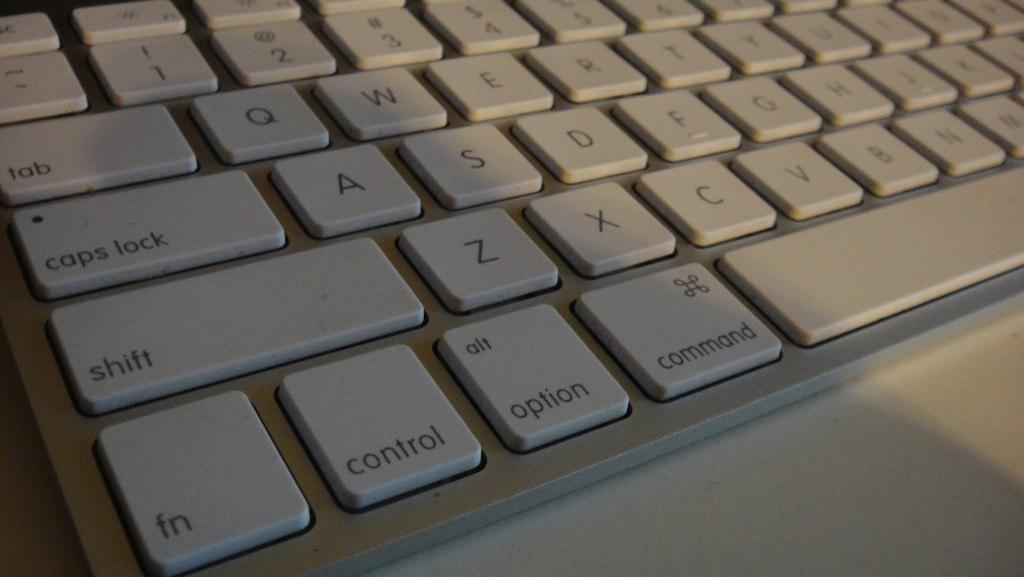What kind of lock key is on the keyboard?
Make the answer very short. Caps. What is the key to the right of the space bar?
Your answer should be compact. Unanswerable. 